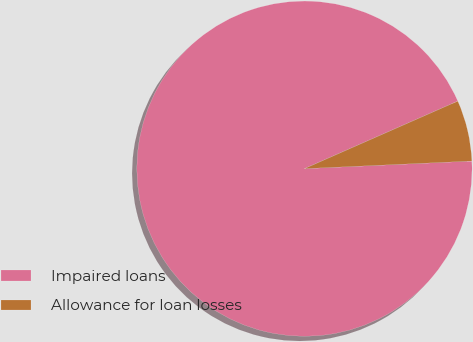<chart> <loc_0><loc_0><loc_500><loc_500><pie_chart><fcel>Impaired loans<fcel>Allowance for loan losses<nl><fcel>94.12%<fcel>5.88%<nl></chart> 